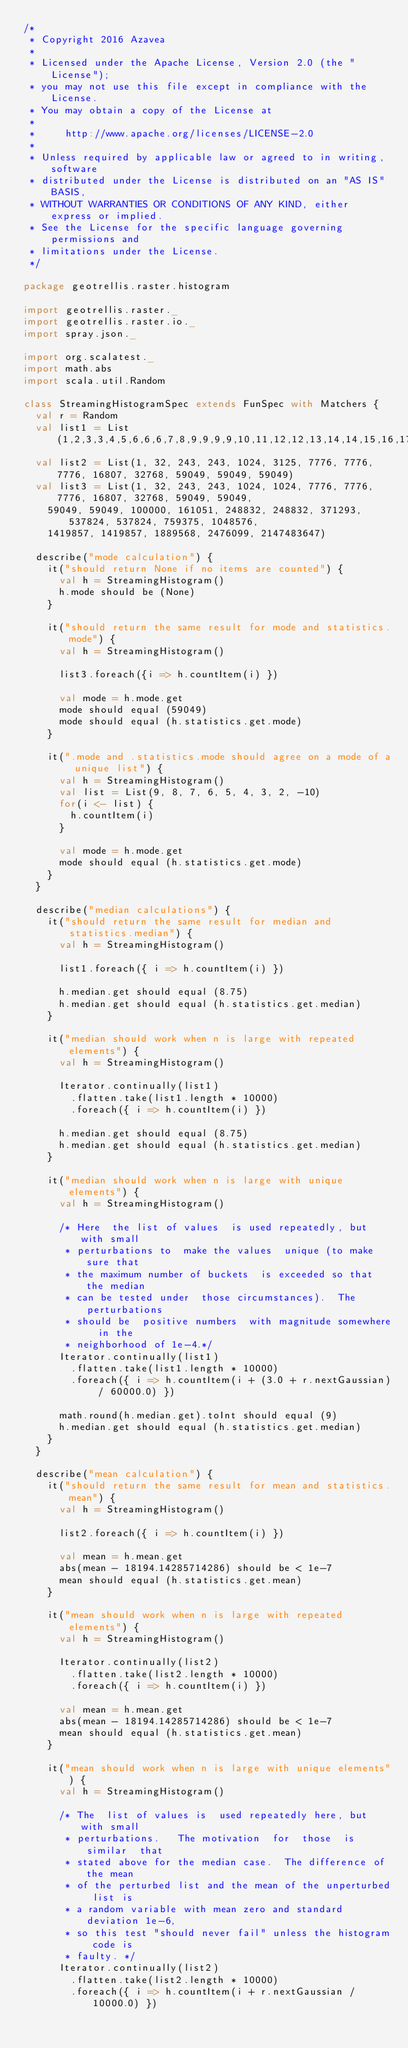Convert code to text. <code><loc_0><loc_0><loc_500><loc_500><_Scala_>/*
 * Copyright 2016 Azavea
 *
 * Licensed under the Apache License, Version 2.0 (the "License");
 * you may not use this file except in compliance with the License.
 * You may obtain a copy of the License at
 *
 *     http://www.apache.org/licenses/LICENSE-2.0
 *
 * Unless required by applicable law or agreed to in writing, software
 * distributed under the License is distributed on an "AS IS" BASIS,
 * WITHOUT WARRANTIES OR CONDITIONS OF ANY KIND, either express or implied.
 * See the License for the specific language governing permissions and
 * limitations under the License.
 */

package geotrellis.raster.histogram

import geotrellis.raster._
import geotrellis.raster.io._
import spray.json._

import org.scalatest._
import math.abs
import scala.util.Random

class StreamingHistogramSpec extends FunSpec with Matchers {
  val r = Random
  val list1 = List(1,2,3,3,4,5,6,6,6,7,8,9,9,9,9,10,11,12,12,13,14,14,15,16,17,17,18,19)
  val list2 = List(1, 32, 243, 243, 1024, 3125, 7776, 7776, 7776, 16807, 32768, 59049, 59049, 59049)
  val list3 = List(1, 32, 243, 243, 1024, 1024, 7776, 7776, 7776, 16807, 32768, 59049, 59049,
    59049, 59049, 100000, 161051, 248832, 248832, 371293, 537824, 537824, 759375, 1048576,
    1419857, 1419857, 1889568, 2476099, 2147483647)

  describe("mode calculation") {
    it("should return None if no items are counted") {
      val h = StreamingHistogram()
      h.mode should be (None)
    }

    it("should return the same result for mode and statistics.mode") {
      val h = StreamingHistogram()

      list3.foreach({i => h.countItem(i) })

      val mode = h.mode.get
      mode should equal (59049)
      mode should equal (h.statistics.get.mode)
    }

    it(".mode and .statistics.mode should agree on a mode of a unique list") {
      val h = StreamingHistogram()
      val list = List(9, 8, 7, 6, 5, 4, 3, 2, -10)
      for(i <- list) {
        h.countItem(i)
      }

      val mode = h.mode.get
      mode should equal (h.statistics.get.mode)
    }
  }

  describe("median calculations") {
    it("should return the same result for median and statistics.median") {
      val h = StreamingHistogram()

      list1.foreach({ i => h.countItem(i) })

      h.median.get should equal (8.75)
      h.median.get should equal (h.statistics.get.median)
    }

    it("median should work when n is large with repeated elements") {
      val h = StreamingHistogram()

      Iterator.continually(list1)
        .flatten.take(list1.length * 10000)
        .foreach({ i => h.countItem(i) })

      h.median.get should equal (8.75)
      h.median.get should equal (h.statistics.get.median)
    }

    it("median should work when n is large with unique elements") {
      val h = StreamingHistogram()

      /* Here  the list of values  is used repeatedly, but  with small
       * perturbations to  make the values  unique (to make  sure that
       * the maximum number of buckets  is exceeded so that the median
       * can be tested under  those circumstances).  The perturbations
       * should be  positive numbers  with magnitude somewhere  in the
       * neighborhood of 1e-4.*/
      Iterator.continually(list1)
        .flatten.take(list1.length * 10000)
        .foreach({ i => h.countItem(i + (3.0 + r.nextGaussian) / 60000.0) })

      math.round(h.median.get).toInt should equal (9)
      h.median.get should equal (h.statistics.get.median)
    }
  }

  describe("mean calculation") {
    it("should return the same result for mean and statistics.mean") {
      val h = StreamingHistogram()

      list2.foreach({ i => h.countItem(i) })

      val mean = h.mean.get
      abs(mean - 18194.14285714286) should be < 1e-7
      mean should equal (h.statistics.get.mean)
    }

    it("mean should work when n is large with repeated elements") {
      val h = StreamingHistogram()

      Iterator.continually(list2)
        .flatten.take(list2.length * 10000)
        .foreach({ i => h.countItem(i) })

      val mean = h.mean.get
      abs(mean - 18194.14285714286) should be < 1e-7
      mean should equal (h.statistics.get.mean)
    }

    it("mean should work when n is large with unique elements") {
      val h = StreamingHistogram()

      /* The  list of values is  used repeatedly here, but  with small
       * perturbations.   The motivation  for  those  is similar  that
       * stated above for the median case.  The difference of the mean
       * of the perturbed list and the mean of the unperturbed list is
       * a random variable with mean zero and standard deviation 1e-6,
       * so this test "should never fail" unless the histogram code is
       * faulty. */
      Iterator.continually(list2)
        .flatten.take(list2.length * 10000)
        .foreach({ i => h.countItem(i + r.nextGaussian / 10000.0) })
</code> 